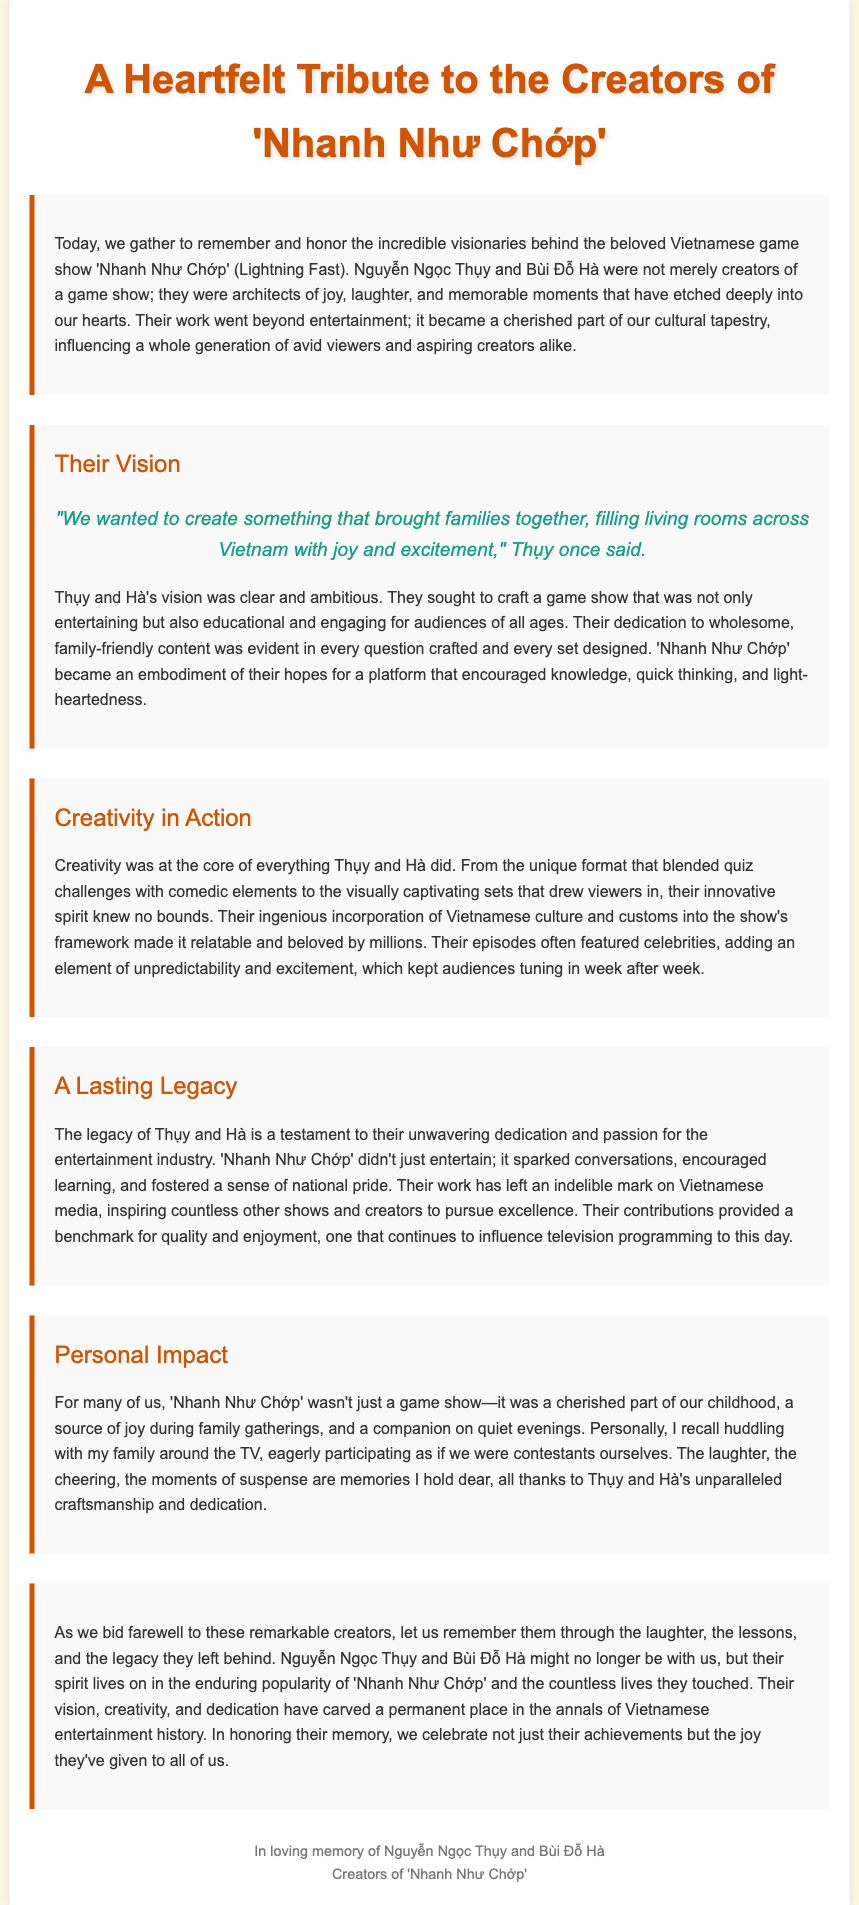What is the title of the game show discussed? The title is stated in the heading of the document.
Answer: 'Nhanh Như Chớp' Who are the creators mentioned in the tribute? The document names both creators prominently in the introduction.
Answer: Nguyễn Ngọc Thụy and Bùi Đỗ Hà What type of content did 'Nhanh Như Chớp' primarily provide? The document discusses the show's focus on entertainment while also being educational.
Answer: Entertainment and education What was a key element of Thụy and Hà's vision for the show? The document quotes Thụy about their intent for family engagement.
Answer: Bringing families together Which cultural aspect did Thụy and Hà incorporate into the show? The tribute highlights their inclusion of Vietnamese culture as a significant component.
Answer: Vietnamese culture How did 'Nhanh Như Chớp' impact viewers personally? The document reflects on individual memories related to family gatherings and enjoyment.
Answer: A cherished part of childhood What is noted as the lasting impact of Thụy and Hà's legacy? The document states that their contributions have inspired other creators and shows.
Answer: Inspired countless other shows What emotional elements does the tribute emphasize about the game show? The document mentions joy, laughter, and memorable moments as central themes.
Answer: Joy and laughter 